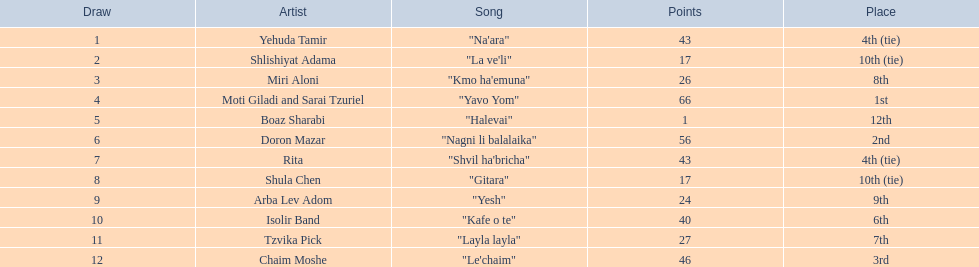How many artists exist? Yehuda Tamir, Shlishiyat Adama, Miri Aloni, Moti Giladi and Sarai Tzuriel, Boaz Sharabi, Doron Mazar, Rita, Shula Chen, Arba Lev Adom, Isolir Band, Tzvika Pick, Chaim Moshe. What's the lowest point value awarded? 1. Give me the full table as a dictionary. {'header': ['Draw', 'Artist', 'Song', 'Points', 'Place'], 'rows': [['1', 'Yehuda Tamir', '"Na\'ara"', '43', '4th (tie)'], ['2', 'Shlishiyat Adama', '"La ve\'li"', '17', '10th (tie)'], ['3', 'Miri Aloni', '"Kmo ha\'emuna"', '26', '8th'], ['4', 'Moti Giladi and Sarai Tzuriel', '"Yavo Yom"', '66', '1st'], ['5', 'Boaz Sharabi', '"Halevai"', '1', '12th'], ['6', 'Doron Mazar', '"Nagni li balalaika"', '56', '2nd'], ['7', 'Rita', '"Shvil ha\'bricha"', '43', '4th (tie)'], ['8', 'Shula Chen', '"Gitara"', '17', '10th (tie)'], ['9', 'Arba Lev Adom', '"Yesh"', '24', '9th'], ['10', 'Isolir Band', '"Kafe o te"', '40', '6th'], ['11', 'Tzvika Pick', '"Layla layla"', '27', '7th'], ['12', 'Chaim Moshe', '"Le\'chaim"', '46', '3rd']]} Who is the artist that got those points? Boaz Sharabi. 